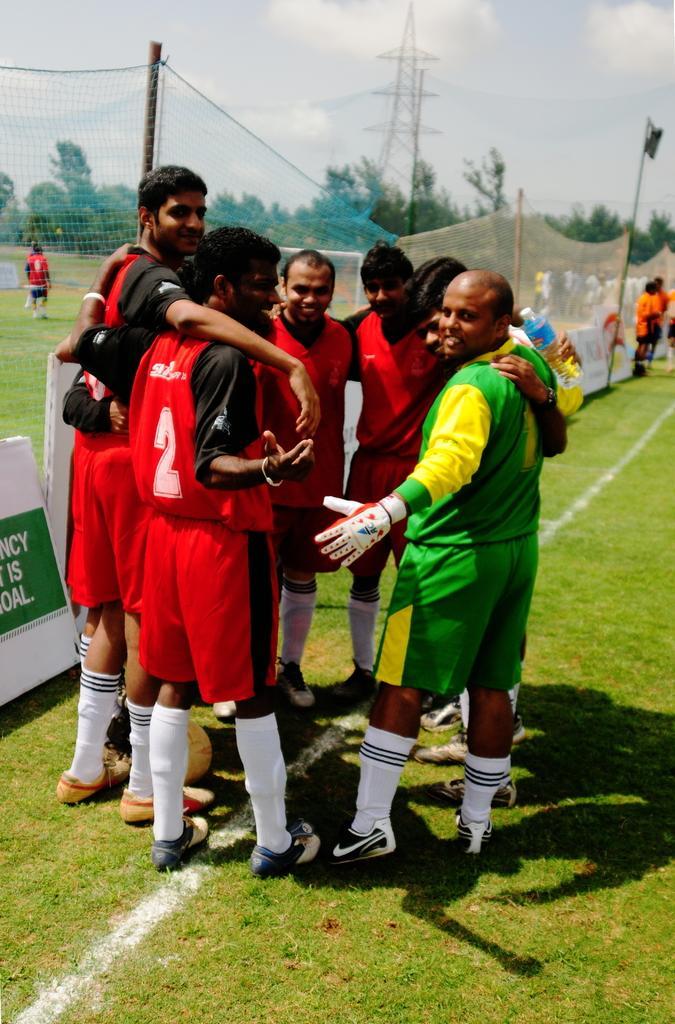In one or two sentences, can you explain what this image depicts? In this image there is a group of persons standing in middle of this image and there is a net wall in the background. As we can see there are some trees in middle of this image and there is a sky on the top of this image. There is a grassy land in the bottom of this image. 